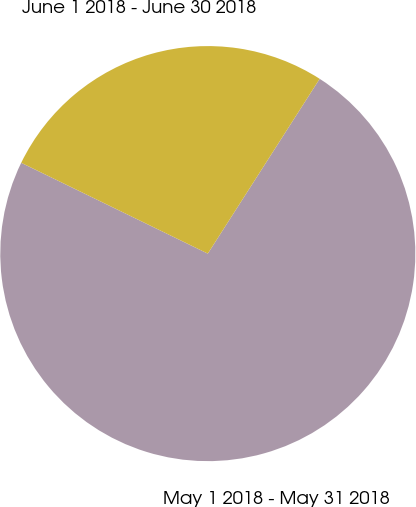<chart> <loc_0><loc_0><loc_500><loc_500><pie_chart><fcel>May 1 2018 - May 31 2018<fcel>June 1 2018 - June 30 2018<nl><fcel>73.15%<fcel>26.85%<nl></chart> 